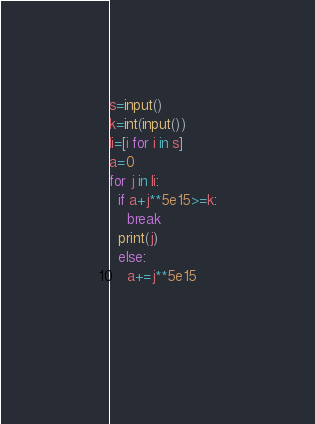<code> <loc_0><loc_0><loc_500><loc_500><_Python_>s=input()
k=int(input())
li=[i for i in s]
a=0
for j in li:
  if a+j**5e15>=k:
    break
  print(j)
  else:
    a+=j**5e15
    
    
</code> 